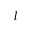<formula> <loc_0><loc_0><loc_500><loc_500>l</formula> 